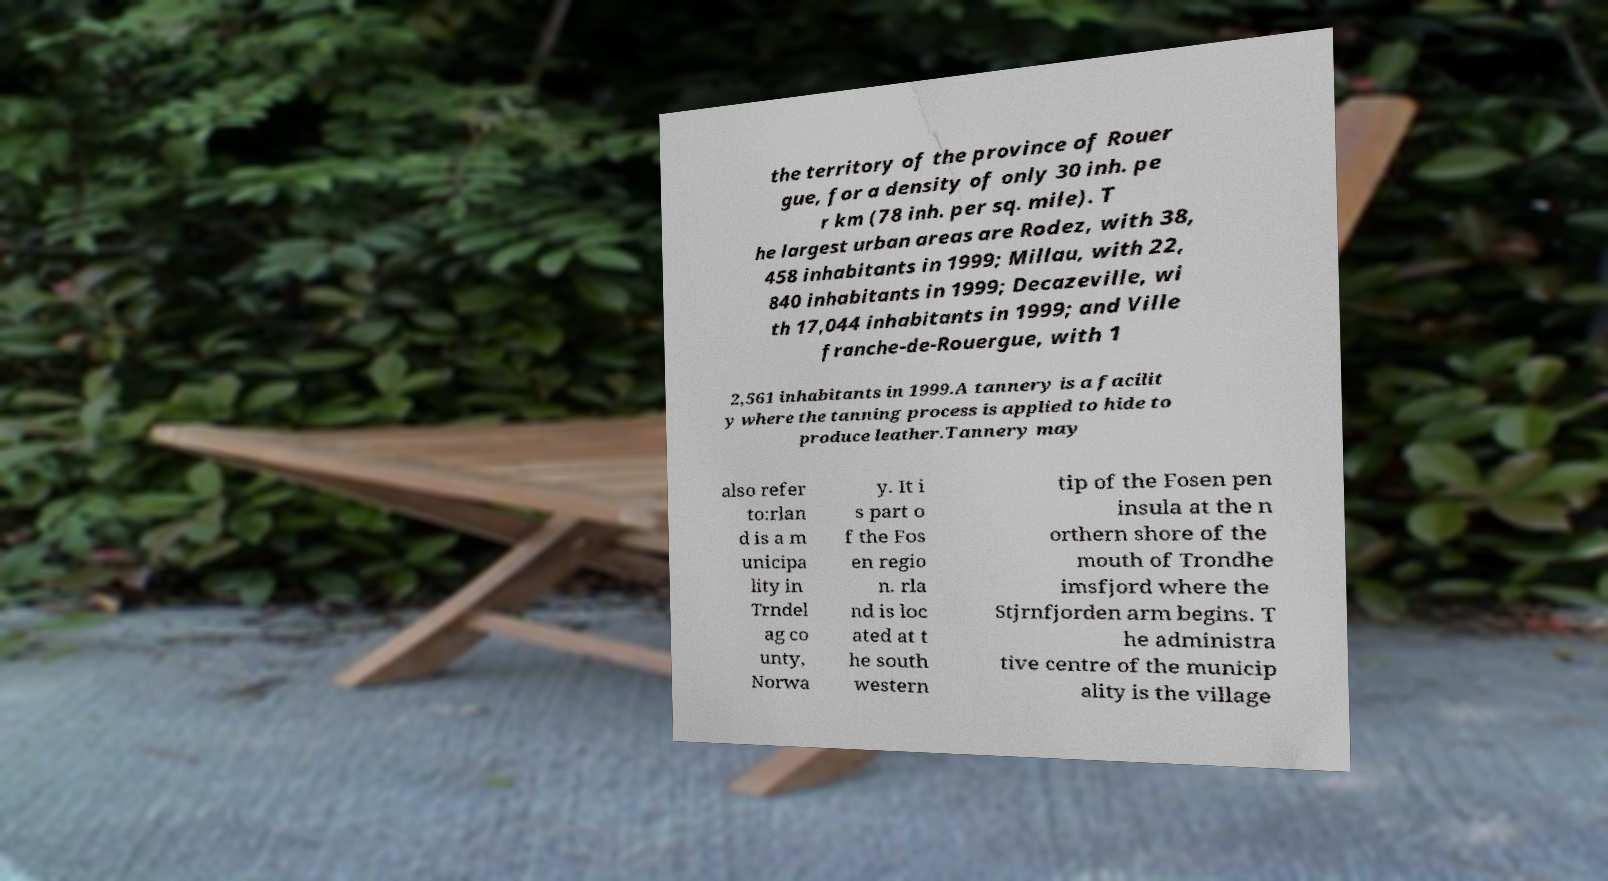There's text embedded in this image that I need extracted. Can you transcribe it verbatim? the territory of the province of Rouer gue, for a density of only 30 inh. pe r km (78 inh. per sq. mile). T he largest urban areas are Rodez, with 38, 458 inhabitants in 1999; Millau, with 22, 840 inhabitants in 1999; Decazeville, wi th 17,044 inhabitants in 1999; and Ville franche-de-Rouergue, with 1 2,561 inhabitants in 1999.A tannery is a facilit y where the tanning process is applied to hide to produce leather.Tannery may also refer to:rlan d is a m unicipa lity in Trndel ag co unty, Norwa y. It i s part o f the Fos en regio n. rla nd is loc ated at t he south western tip of the Fosen pen insula at the n orthern shore of the mouth of Trondhe imsfjord where the Stjrnfjorden arm begins. T he administra tive centre of the municip ality is the village 